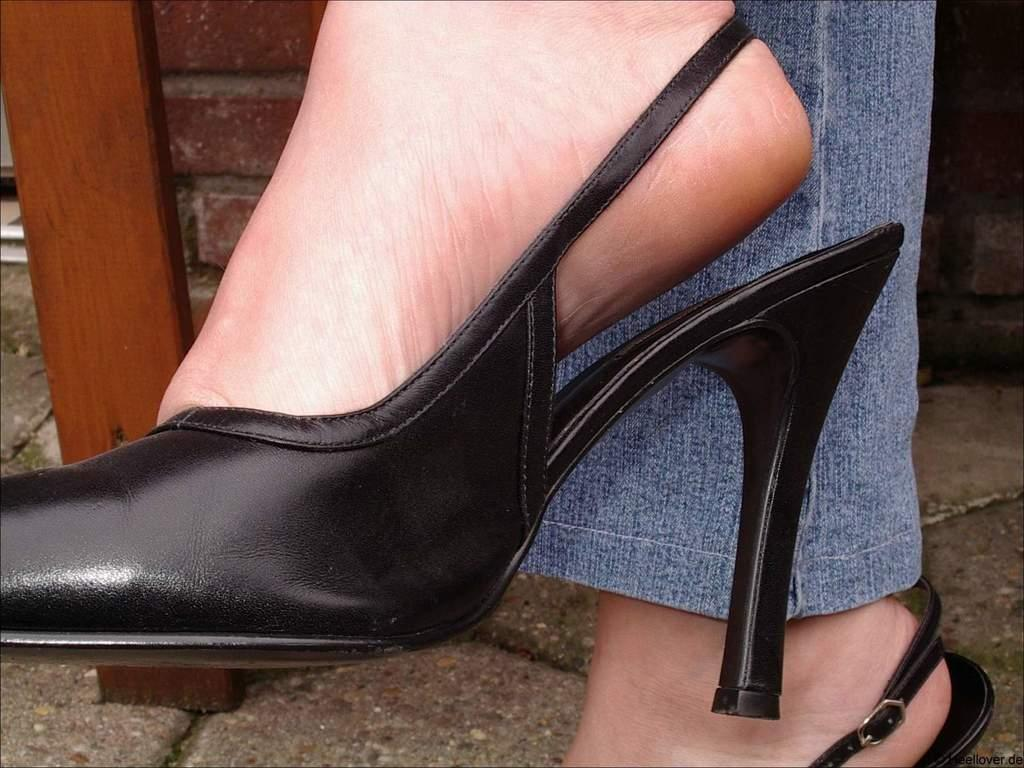What part of a person's body is visible in the image? There is a person's feet in the image. What type of footwear is the person wearing? The person's feet are wearing black sandals. What is the person's belief about the current political scene in the year 2025? There is no information about the person's beliefs or the political scene in the year 2025 in the image. 